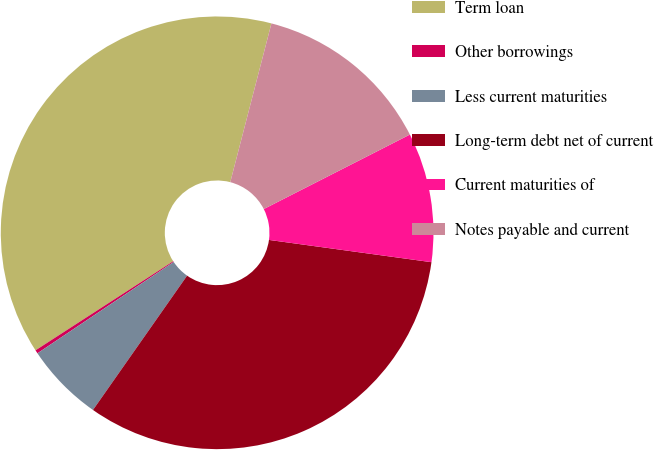Convert chart. <chart><loc_0><loc_0><loc_500><loc_500><pie_chart><fcel>Term loan<fcel>Other borrowings<fcel>Less current maturities<fcel>Long-term debt net of current<fcel>Current maturities of<fcel>Notes payable and current<nl><fcel>38.18%<fcel>0.26%<fcel>5.87%<fcel>32.56%<fcel>9.67%<fcel>13.46%<nl></chart> 